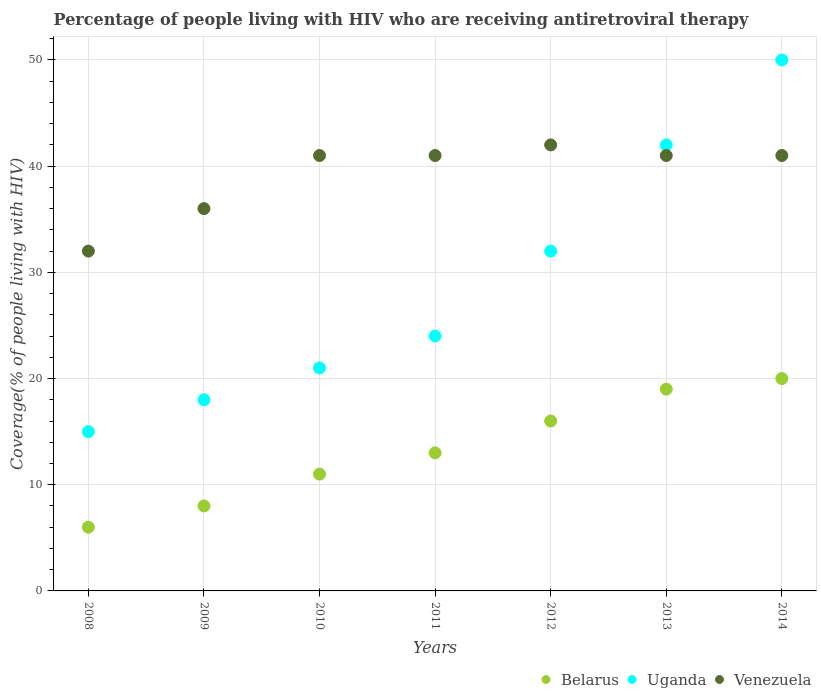How many different coloured dotlines are there?
Keep it short and to the point. 3. What is the percentage of the HIV infected people who are receiving antiretroviral therapy in Venezuela in 2014?
Your response must be concise. 41. Across all years, what is the maximum percentage of the HIV infected people who are receiving antiretroviral therapy in Uganda?
Offer a very short reply. 50. Across all years, what is the minimum percentage of the HIV infected people who are receiving antiretroviral therapy in Uganda?
Keep it short and to the point. 15. What is the total percentage of the HIV infected people who are receiving antiretroviral therapy in Uganda in the graph?
Your response must be concise. 202. What is the difference between the percentage of the HIV infected people who are receiving antiretroviral therapy in Venezuela in 2009 and that in 2013?
Keep it short and to the point. -5. What is the difference between the percentage of the HIV infected people who are receiving antiretroviral therapy in Venezuela in 2014 and the percentage of the HIV infected people who are receiving antiretroviral therapy in Belarus in 2008?
Provide a succinct answer. 35. What is the average percentage of the HIV infected people who are receiving antiretroviral therapy in Uganda per year?
Provide a succinct answer. 28.86. In the year 2014, what is the difference between the percentage of the HIV infected people who are receiving antiretroviral therapy in Uganda and percentage of the HIV infected people who are receiving antiretroviral therapy in Venezuela?
Your answer should be very brief. 9. In how many years, is the percentage of the HIV infected people who are receiving antiretroviral therapy in Belarus greater than 12 %?
Give a very brief answer. 4. What is the ratio of the percentage of the HIV infected people who are receiving antiretroviral therapy in Uganda in 2011 to that in 2014?
Offer a very short reply. 0.48. What is the difference between the highest and the lowest percentage of the HIV infected people who are receiving antiretroviral therapy in Uganda?
Ensure brevity in your answer.  35. Is the sum of the percentage of the HIV infected people who are receiving antiretroviral therapy in Belarus in 2010 and 2014 greater than the maximum percentage of the HIV infected people who are receiving antiretroviral therapy in Uganda across all years?
Your answer should be compact. No. Is it the case that in every year, the sum of the percentage of the HIV infected people who are receiving antiretroviral therapy in Venezuela and percentage of the HIV infected people who are receiving antiretroviral therapy in Belarus  is greater than the percentage of the HIV infected people who are receiving antiretroviral therapy in Uganda?
Your answer should be compact. Yes. Is the percentage of the HIV infected people who are receiving antiretroviral therapy in Belarus strictly greater than the percentage of the HIV infected people who are receiving antiretroviral therapy in Uganda over the years?
Offer a very short reply. No. What is the difference between two consecutive major ticks on the Y-axis?
Offer a terse response. 10. Are the values on the major ticks of Y-axis written in scientific E-notation?
Provide a succinct answer. No. Does the graph contain any zero values?
Your answer should be very brief. No. How are the legend labels stacked?
Offer a terse response. Horizontal. What is the title of the graph?
Make the answer very short. Percentage of people living with HIV who are receiving antiretroviral therapy. What is the label or title of the X-axis?
Ensure brevity in your answer.  Years. What is the label or title of the Y-axis?
Offer a terse response. Coverage(% of people living with HIV). What is the Coverage(% of people living with HIV) of Belarus in 2008?
Provide a succinct answer. 6. What is the Coverage(% of people living with HIV) in Uganda in 2008?
Provide a succinct answer. 15. What is the Coverage(% of people living with HIV) in Venezuela in 2009?
Ensure brevity in your answer.  36. What is the Coverage(% of people living with HIV) of Belarus in 2010?
Your answer should be compact. 11. What is the Coverage(% of people living with HIV) of Uganda in 2010?
Make the answer very short. 21. What is the Coverage(% of people living with HIV) in Venezuela in 2010?
Offer a terse response. 41. What is the Coverage(% of people living with HIV) of Belarus in 2011?
Your response must be concise. 13. What is the Coverage(% of people living with HIV) of Venezuela in 2011?
Ensure brevity in your answer.  41. What is the Coverage(% of people living with HIV) of Belarus in 2012?
Your answer should be very brief. 16. What is the Coverage(% of people living with HIV) in Venezuela in 2012?
Your response must be concise. 42. What is the Coverage(% of people living with HIV) of Venezuela in 2013?
Make the answer very short. 41. What is the Coverage(% of people living with HIV) in Uganda in 2014?
Provide a succinct answer. 50. What is the Coverage(% of people living with HIV) in Venezuela in 2014?
Your response must be concise. 41. Across all years, what is the maximum Coverage(% of people living with HIV) of Belarus?
Keep it short and to the point. 20. Across all years, what is the maximum Coverage(% of people living with HIV) of Uganda?
Give a very brief answer. 50. Across all years, what is the maximum Coverage(% of people living with HIV) in Venezuela?
Provide a short and direct response. 42. Across all years, what is the minimum Coverage(% of people living with HIV) in Belarus?
Ensure brevity in your answer.  6. Across all years, what is the minimum Coverage(% of people living with HIV) in Uganda?
Give a very brief answer. 15. What is the total Coverage(% of people living with HIV) in Belarus in the graph?
Your response must be concise. 93. What is the total Coverage(% of people living with HIV) in Uganda in the graph?
Offer a terse response. 202. What is the total Coverage(% of people living with HIV) in Venezuela in the graph?
Provide a short and direct response. 274. What is the difference between the Coverage(% of people living with HIV) of Uganda in 2008 and that in 2009?
Keep it short and to the point. -3. What is the difference between the Coverage(% of people living with HIV) in Venezuela in 2008 and that in 2009?
Give a very brief answer. -4. What is the difference between the Coverage(% of people living with HIV) in Uganda in 2008 and that in 2010?
Offer a terse response. -6. What is the difference between the Coverage(% of people living with HIV) of Belarus in 2008 and that in 2011?
Keep it short and to the point. -7. What is the difference between the Coverage(% of people living with HIV) of Uganda in 2008 and that in 2011?
Keep it short and to the point. -9. What is the difference between the Coverage(% of people living with HIV) of Venezuela in 2008 and that in 2011?
Offer a terse response. -9. What is the difference between the Coverage(% of people living with HIV) in Belarus in 2008 and that in 2012?
Offer a very short reply. -10. What is the difference between the Coverage(% of people living with HIV) of Uganda in 2008 and that in 2012?
Provide a succinct answer. -17. What is the difference between the Coverage(% of people living with HIV) of Venezuela in 2008 and that in 2012?
Offer a very short reply. -10. What is the difference between the Coverage(% of people living with HIV) in Belarus in 2008 and that in 2013?
Offer a very short reply. -13. What is the difference between the Coverage(% of people living with HIV) in Venezuela in 2008 and that in 2013?
Ensure brevity in your answer.  -9. What is the difference between the Coverage(% of people living with HIV) in Uganda in 2008 and that in 2014?
Offer a very short reply. -35. What is the difference between the Coverage(% of people living with HIV) of Venezuela in 2008 and that in 2014?
Offer a very short reply. -9. What is the difference between the Coverage(% of people living with HIV) in Venezuela in 2009 and that in 2010?
Keep it short and to the point. -5. What is the difference between the Coverage(% of people living with HIV) in Belarus in 2009 and that in 2012?
Offer a very short reply. -8. What is the difference between the Coverage(% of people living with HIV) of Uganda in 2009 and that in 2012?
Make the answer very short. -14. What is the difference between the Coverage(% of people living with HIV) in Venezuela in 2009 and that in 2012?
Your answer should be compact. -6. What is the difference between the Coverage(% of people living with HIV) in Uganda in 2009 and that in 2013?
Make the answer very short. -24. What is the difference between the Coverage(% of people living with HIV) of Venezuela in 2009 and that in 2013?
Your answer should be compact. -5. What is the difference between the Coverage(% of people living with HIV) of Belarus in 2009 and that in 2014?
Offer a very short reply. -12. What is the difference between the Coverage(% of people living with HIV) of Uganda in 2009 and that in 2014?
Provide a succinct answer. -32. What is the difference between the Coverage(% of people living with HIV) of Belarus in 2010 and that in 2011?
Provide a succinct answer. -2. What is the difference between the Coverage(% of people living with HIV) of Venezuela in 2010 and that in 2013?
Your response must be concise. 0. What is the difference between the Coverage(% of people living with HIV) of Belarus in 2010 and that in 2014?
Offer a very short reply. -9. What is the difference between the Coverage(% of people living with HIV) of Uganda in 2010 and that in 2014?
Your response must be concise. -29. What is the difference between the Coverage(% of people living with HIV) in Venezuela in 2010 and that in 2014?
Offer a very short reply. 0. What is the difference between the Coverage(% of people living with HIV) of Belarus in 2011 and that in 2012?
Your response must be concise. -3. What is the difference between the Coverage(% of people living with HIV) of Uganda in 2011 and that in 2012?
Your answer should be very brief. -8. What is the difference between the Coverage(% of people living with HIV) of Uganda in 2011 and that in 2013?
Your answer should be very brief. -18. What is the difference between the Coverage(% of people living with HIV) in Venezuela in 2012 and that in 2013?
Keep it short and to the point. 1. What is the difference between the Coverage(% of people living with HIV) of Belarus in 2012 and that in 2014?
Your answer should be compact. -4. What is the difference between the Coverage(% of people living with HIV) of Venezuela in 2012 and that in 2014?
Make the answer very short. 1. What is the difference between the Coverage(% of people living with HIV) in Belarus in 2013 and that in 2014?
Your answer should be compact. -1. What is the difference between the Coverage(% of people living with HIV) in Belarus in 2008 and the Coverage(% of people living with HIV) in Uganda in 2009?
Offer a terse response. -12. What is the difference between the Coverage(% of people living with HIV) in Belarus in 2008 and the Coverage(% of people living with HIV) in Venezuela in 2009?
Offer a terse response. -30. What is the difference between the Coverage(% of people living with HIV) in Uganda in 2008 and the Coverage(% of people living with HIV) in Venezuela in 2009?
Your response must be concise. -21. What is the difference between the Coverage(% of people living with HIV) in Belarus in 2008 and the Coverage(% of people living with HIV) in Uganda in 2010?
Your response must be concise. -15. What is the difference between the Coverage(% of people living with HIV) of Belarus in 2008 and the Coverage(% of people living with HIV) of Venezuela in 2010?
Your response must be concise. -35. What is the difference between the Coverage(% of people living with HIV) of Uganda in 2008 and the Coverage(% of people living with HIV) of Venezuela in 2010?
Your answer should be compact. -26. What is the difference between the Coverage(% of people living with HIV) in Belarus in 2008 and the Coverage(% of people living with HIV) in Venezuela in 2011?
Offer a terse response. -35. What is the difference between the Coverage(% of people living with HIV) in Uganda in 2008 and the Coverage(% of people living with HIV) in Venezuela in 2011?
Offer a terse response. -26. What is the difference between the Coverage(% of people living with HIV) of Belarus in 2008 and the Coverage(% of people living with HIV) of Venezuela in 2012?
Give a very brief answer. -36. What is the difference between the Coverage(% of people living with HIV) in Uganda in 2008 and the Coverage(% of people living with HIV) in Venezuela in 2012?
Your answer should be very brief. -27. What is the difference between the Coverage(% of people living with HIV) in Belarus in 2008 and the Coverage(% of people living with HIV) in Uganda in 2013?
Offer a terse response. -36. What is the difference between the Coverage(% of people living with HIV) of Belarus in 2008 and the Coverage(% of people living with HIV) of Venezuela in 2013?
Your response must be concise. -35. What is the difference between the Coverage(% of people living with HIV) of Uganda in 2008 and the Coverage(% of people living with HIV) of Venezuela in 2013?
Offer a very short reply. -26. What is the difference between the Coverage(% of people living with HIV) of Belarus in 2008 and the Coverage(% of people living with HIV) of Uganda in 2014?
Keep it short and to the point. -44. What is the difference between the Coverage(% of people living with HIV) in Belarus in 2008 and the Coverage(% of people living with HIV) in Venezuela in 2014?
Offer a very short reply. -35. What is the difference between the Coverage(% of people living with HIV) of Belarus in 2009 and the Coverage(% of people living with HIV) of Venezuela in 2010?
Your answer should be very brief. -33. What is the difference between the Coverage(% of people living with HIV) of Uganda in 2009 and the Coverage(% of people living with HIV) of Venezuela in 2010?
Provide a succinct answer. -23. What is the difference between the Coverage(% of people living with HIV) of Belarus in 2009 and the Coverage(% of people living with HIV) of Venezuela in 2011?
Provide a succinct answer. -33. What is the difference between the Coverage(% of people living with HIV) of Uganda in 2009 and the Coverage(% of people living with HIV) of Venezuela in 2011?
Your answer should be compact. -23. What is the difference between the Coverage(% of people living with HIV) of Belarus in 2009 and the Coverage(% of people living with HIV) of Venezuela in 2012?
Give a very brief answer. -34. What is the difference between the Coverage(% of people living with HIV) in Uganda in 2009 and the Coverage(% of people living with HIV) in Venezuela in 2012?
Your answer should be very brief. -24. What is the difference between the Coverage(% of people living with HIV) of Belarus in 2009 and the Coverage(% of people living with HIV) of Uganda in 2013?
Ensure brevity in your answer.  -34. What is the difference between the Coverage(% of people living with HIV) in Belarus in 2009 and the Coverage(% of people living with HIV) in Venezuela in 2013?
Keep it short and to the point. -33. What is the difference between the Coverage(% of people living with HIV) in Belarus in 2009 and the Coverage(% of people living with HIV) in Uganda in 2014?
Provide a succinct answer. -42. What is the difference between the Coverage(% of people living with HIV) of Belarus in 2009 and the Coverage(% of people living with HIV) of Venezuela in 2014?
Keep it short and to the point. -33. What is the difference between the Coverage(% of people living with HIV) of Belarus in 2010 and the Coverage(% of people living with HIV) of Uganda in 2012?
Your answer should be compact. -21. What is the difference between the Coverage(% of people living with HIV) in Belarus in 2010 and the Coverage(% of people living with HIV) in Venezuela in 2012?
Keep it short and to the point. -31. What is the difference between the Coverage(% of people living with HIV) in Belarus in 2010 and the Coverage(% of people living with HIV) in Uganda in 2013?
Provide a short and direct response. -31. What is the difference between the Coverage(% of people living with HIV) in Belarus in 2010 and the Coverage(% of people living with HIV) in Uganda in 2014?
Provide a succinct answer. -39. What is the difference between the Coverage(% of people living with HIV) in Uganda in 2010 and the Coverage(% of people living with HIV) in Venezuela in 2014?
Provide a succinct answer. -20. What is the difference between the Coverage(% of people living with HIV) in Belarus in 2011 and the Coverage(% of people living with HIV) in Venezuela in 2013?
Give a very brief answer. -28. What is the difference between the Coverage(% of people living with HIV) of Uganda in 2011 and the Coverage(% of people living with HIV) of Venezuela in 2013?
Your answer should be compact. -17. What is the difference between the Coverage(% of people living with HIV) in Belarus in 2011 and the Coverage(% of people living with HIV) in Uganda in 2014?
Provide a succinct answer. -37. What is the difference between the Coverage(% of people living with HIV) in Uganda in 2011 and the Coverage(% of people living with HIV) in Venezuela in 2014?
Your response must be concise. -17. What is the difference between the Coverage(% of people living with HIV) of Belarus in 2012 and the Coverage(% of people living with HIV) of Uganda in 2013?
Your response must be concise. -26. What is the difference between the Coverage(% of people living with HIV) of Belarus in 2012 and the Coverage(% of people living with HIV) of Venezuela in 2013?
Provide a short and direct response. -25. What is the difference between the Coverage(% of people living with HIV) of Uganda in 2012 and the Coverage(% of people living with HIV) of Venezuela in 2013?
Your response must be concise. -9. What is the difference between the Coverage(% of people living with HIV) in Belarus in 2012 and the Coverage(% of people living with HIV) in Uganda in 2014?
Your answer should be compact. -34. What is the difference between the Coverage(% of people living with HIV) in Belarus in 2013 and the Coverage(% of people living with HIV) in Uganda in 2014?
Provide a succinct answer. -31. What is the difference between the Coverage(% of people living with HIV) of Uganda in 2013 and the Coverage(% of people living with HIV) of Venezuela in 2014?
Offer a terse response. 1. What is the average Coverage(% of people living with HIV) in Belarus per year?
Your answer should be compact. 13.29. What is the average Coverage(% of people living with HIV) in Uganda per year?
Give a very brief answer. 28.86. What is the average Coverage(% of people living with HIV) of Venezuela per year?
Offer a terse response. 39.14. In the year 2008, what is the difference between the Coverage(% of people living with HIV) of Uganda and Coverage(% of people living with HIV) of Venezuela?
Give a very brief answer. -17. In the year 2009, what is the difference between the Coverage(% of people living with HIV) of Belarus and Coverage(% of people living with HIV) of Venezuela?
Offer a terse response. -28. In the year 2010, what is the difference between the Coverage(% of people living with HIV) of Belarus and Coverage(% of people living with HIV) of Uganda?
Make the answer very short. -10. In the year 2011, what is the difference between the Coverage(% of people living with HIV) of Belarus and Coverage(% of people living with HIV) of Uganda?
Ensure brevity in your answer.  -11. In the year 2012, what is the difference between the Coverage(% of people living with HIV) of Belarus and Coverage(% of people living with HIV) of Uganda?
Provide a short and direct response. -16. In the year 2013, what is the difference between the Coverage(% of people living with HIV) in Belarus and Coverage(% of people living with HIV) in Venezuela?
Your response must be concise. -22. In the year 2013, what is the difference between the Coverage(% of people living with HIV) in Uganda and Coverage(% of people living with HIV) in Venezuela?
Ensure brevity in your answer.  1. In the year 2014, what is the difference between the Coverage(% of people living with HIV) of Belarus and Coverage(% of people living with HIV) of Venezuela?
Make the answer very short. -21. In the year 2014, what is the difference between the Coverage(% of people living with HIV) in Uganda and Coverage(% of people living with HIV) in Venezuela?
Your answer should be compact. 9. What is the ratio of the Coverage(% of people living with HIV) in Belarus in 2008 to that in 2009?
Offer a terse response. 0.75. What is the ratio of the Coverage(% of people living with HIV) of Belarus in 2008 to that in 2010?
Offer a very short reply. 0.55. What is the ratio of the Coverage(% of people living with HIV) in Uganda in 2008 to that in 2010?
Provide a succinct answer. 0.71. What is the ratio of the Coverage(% of people living with HIV) of Venezuela in 2008 to that in 2010?
Keep it short and to the point. 0.78. What is the ratio of the Coverage(% of people living with HIV) of Belarus in 2008 to that in 2011?
Offer a very short reply. 0.46. What is the ratio of the Coverage(% of people living with HIV) in Venezuela in 2008 to that in 2011?
Offer a very short reply. 0.78. What is the ratio of the Coverage(% of people living with HIV) of Belarus in 2008 to that in 2012?
Your answer should be very brief. 0.38. What is the ratio of the Coverage(% of people living with HIV) in Uganda in 2008 to that in 2012?
Your answer should be very brief. 0.47. What is the ratio of the Coverage(% of people living with HIV) in Venezuela in 2008 to that in 2012?
Provide a succinct answer. 0.76. What is the ratio of the Coverage(% of people living with HIV) of Belarus in 2008 to that in 2013?
Ensure brevity in your answer.  0.32. What is the ratio of the Coverage(% of people living with HIV) of Uganda in 2008 to that in 2013?
Provide a short and direct response. 0.36. What is the ratio of the Coverage(% of people living with HIV) of Venezuela in 2008 to that in 2013?
Make the answer very short. 0.78. What is the ratio of the Coverage(% of people living with HIV) of Belarus in 2008 to that in 2014?
Ensure brevity in your answer.  0.3. What is the ratio of the Coverage(% of people living with HIV) in Uganda in 2008 to that in 2014?
Offer a terse response. 0.3. What is the ratio of the Coverage(% of people living with HIV) in Venezuela in 2008 to that in 2014?
Offer a very short reply. 0.78. What is the ratio of the Coverage(% of people living with HIV) of Belarus in 2009 to that in 2010?
Your answer should be very brief. 0.73. What is the ratio of the Coverage(% of people living with HIV) of Venezuela in 2009 to that in 2010?
Offer a very short reply. 0.88. What is the ratio of the Coverage(% of people living with HIV) in Belarus in 2009 to that in 2011?
Offer a very short reply. 0.62. What is the ratio of the Coverage(% of people living with HIV) of Venezuela in 2009 to that in 2011?
Your response must be concise. 0.88. What is the ratio of the Coverage(% of people living with HIV) in Belarus in 2009 to that in 2012?
Keep it short and to the point. 0.5. What is the ratio of the Coverage(% of people living with HIV) of Uganda in 2009 to that in 2012?
Provide a succinct answer. 0.56. What is the ratio of the Coverage(% of people living with HIV) of Belarus in 2009 to that in 2013?
Your answer should be very brief. 0.42. What is the ratio of the Coverage(% of people living with HIV) in Uganda in 2009 to that in 2013?
Make the answer very short. 0.43. What is the ratio of the Coverage(% of people living with HIV) in Venezuela in 2009 to that in 2013?
Offer a very short reply. 0.88. What is the ratio of the Coverage(% of people living with HIV) in Belarus in 2009 to that in 2014?
Your response must be concise. 0.4. What is the ratio of the Coverage(% of people living with HIV) in Uganda in 2009 to that in 2014?
Give a very brief answer. 0.36. What is the ratio of the Coverage(% of people living with HIV) of Venezuela in 2009 to that in 2014?
Provide a succinct answer. 0.88. What is the ratio of the Coverage(% of people living with HIV) in Belarus in 2010 to that in 2011?
Your answer should be very brief. 0.85. What is the ratio of the Coverage(% of people living with HIV) in Belarus in 2010 to that in 2012?
Your answer should be very brief. 0.69. What is the ratio of the Coverage(% of people living with HIV) in Uganda in 2010 to that in 2012?
Your answer should be very brief. 0.66. What is the ratio of the Coverage(% of people living with HIV) of Venezuela in 2010 to that in 2012?
Provide a succinct answer. 0.98. What is the ratio of the Coverage(% of people living with HIV) in Belarus in 2010 to that in 2013?
Offer a very short reply. 0.58. What is the ratio of the Coverage(% of people living with HIV) in Uganda in 2010 to that in 2013?
Keep it short and to the point. 0.5. What is the ratio of the Coverage(% of people living with HIV) of Venezuela in 2010 to that in 2013?
Provide a short and direct response. 1. What is the ratio of the Coverage(% of people living with HIV) of Belarus in 2010 to that in 2014?
Provide a succinct answer. 0.55. What is the ratio of the Coverage(% of people living with HIV) in Uganda in 2010 to that in 2014?
Your answer should be compact. 0.42. What is the ratio of the Coverage(% of people living with HIV) of Belarus in 2011 to that in 2012?
Keep it short and to the point. 0.81. What is the ratio of the Coverage(% of people living with HIV) in Venezuela in 2011 to that in 2012?
Offer a terse response. 0.98. What is the ratio of the Coverage(% of people living with HIV) in Belarus in 2011 to that in 2013?
Your answer should be compact. 0.68. What is the ratio of the Coverage(% of people living with HIV) of Belarus in 2011 to that in 2014?
Your answer should be compact. 0.65. What is the ratio of the Coverage(% of people living with HIV) in Uganda in 2011 to that in 2014?
Offer a very short reply. 0.48. What is the ratio of the Coverage(% of people living with HIV) in Venezuela in 2011 to that in 2014?
Your response must be concise. 1. What is the ratio of the Coverage(% of people living with HIV) of Belarus in 2012 to that in 2013?
Offer a terse response. 0.84. What is the ratio of the Coverage(% of people living with HIV) in Uganda in 2012 to that in 2013?
Provide a short and direct response. 0.76. What is the ratio of the Coverage(% of people living with HIV) of Venezuela in 2012 to that in 2013?
Your response must be concise. 1.02. What is the ratio of the Coverage(% of people living with HIV) in Belarus in 2012 to that in 2014?
Your answer should be compact. 0.8. What is the ratio of the Coverage(% of people living with HIV) of Uganda in 2012 to that in 2014?
Your answer should be very brief. 0.64. What is the ratio of the Coverage(% of people living with HIV) in Venezuela in 2012 to that in 2014?
Offer a terse response. 1.02. What is the ratio of the Coverage(% of people living with HIV) of Uganda in 2013 to that in 2014?
Provide a succinct answer. 0.84. What is the ratio of the Coverage(% of people living with HIV) in Venezuela in 2013 to that in 2014?
Offer a very short reply. 1. What is the difference between the highest and the lowest Coverage(% of people living with HIV) in Belarus?
Offer a terse response. 14. 